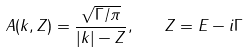Convert formula to latex. <formula><loc_0><loc_0><loc_500><loc_500>A ( k , Z ) = \frac { \sqrt { \Gamma / \pi } } { | k | - Z } , \quad Z = E - i \Gamma</formula> 